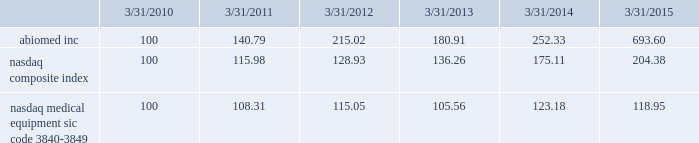Performance graph the following graph compares the yearly change in the cumulative total stockholder return for our last five full fiscal years , based upon the market price of our common stock , with the cumulative total return on a nasdaq composite index ( u.s .
Companies ) and a peer group , the nasdaq medical equipment-sic code 3840-3849 index , which is comprised of medical equipment companies , for that period .
The performance graph assumes the investment of $ 100 on march 31 , 2010 in our common stock , the nasdaq composite index ( u.s .
Companies ) and the peer group index , and the reinvestment of any and all dividends. .
This graph is not 201csoliciting material 201d under regulation 14a or 14c of the rules promulgated under the securities exchange act of 1934 , is not deemed filed with the securities and exchange commission and is not to be incorporated by reference in any of our filings under the securities act of 1933 , as amended , or the exchange act whether made before or after the date hereof and irrespective of any general incorporation language in any such filing .
Transfer agent american stock transfer & trust company , 59 maiden lane , new york , ny 10038 , is our stock transfer agent. .
Did abiomed outperform the nasdaq medical equipment index over the five year period? 
Computations: (693.60 > 118.95)
Answer: yes. Performance graph the following graph compares the yearly change in the cumulative total stockholder return for our last five full fiscal years , based upon the market price of our common stock , with the cumulative total return on a nasdaq composite index ( u.s .
Companies ) and a peer group , the nasdaq medical equipment-sic code 3840-3849 index , which is comprised of medical equipment companies , for that period .
The performance graph assumes the investment of $ 100 on march 31 , 2010 in our common stock , the nasdaq composite index ( u.s .
Companies ) and the peer group index , and the reinvestment of any and all dividends. .
This graph is not 201csoliciting material 201d under regulation 14a or 14c of the rules promulgated under the securities exchange act of 1934 , is not deemed filed with the securities and exchange commission and is not to be incorporated by reference in any of our filings under the securities act of 1933 , as amended , or the exchange act whether made before or after the date hereof and irrespective of any general incorporation language in any such filing .
Transfer agent american stock transfer & trust company , 59 maiden lane , new york , ny 10038 , is our stock transfer agent. .
What is the roi of an investment in abiomed inc from march 2010 to march 2013? 
Computations: ((180.91 - 100) / 100)
Answer: 0.8091. 